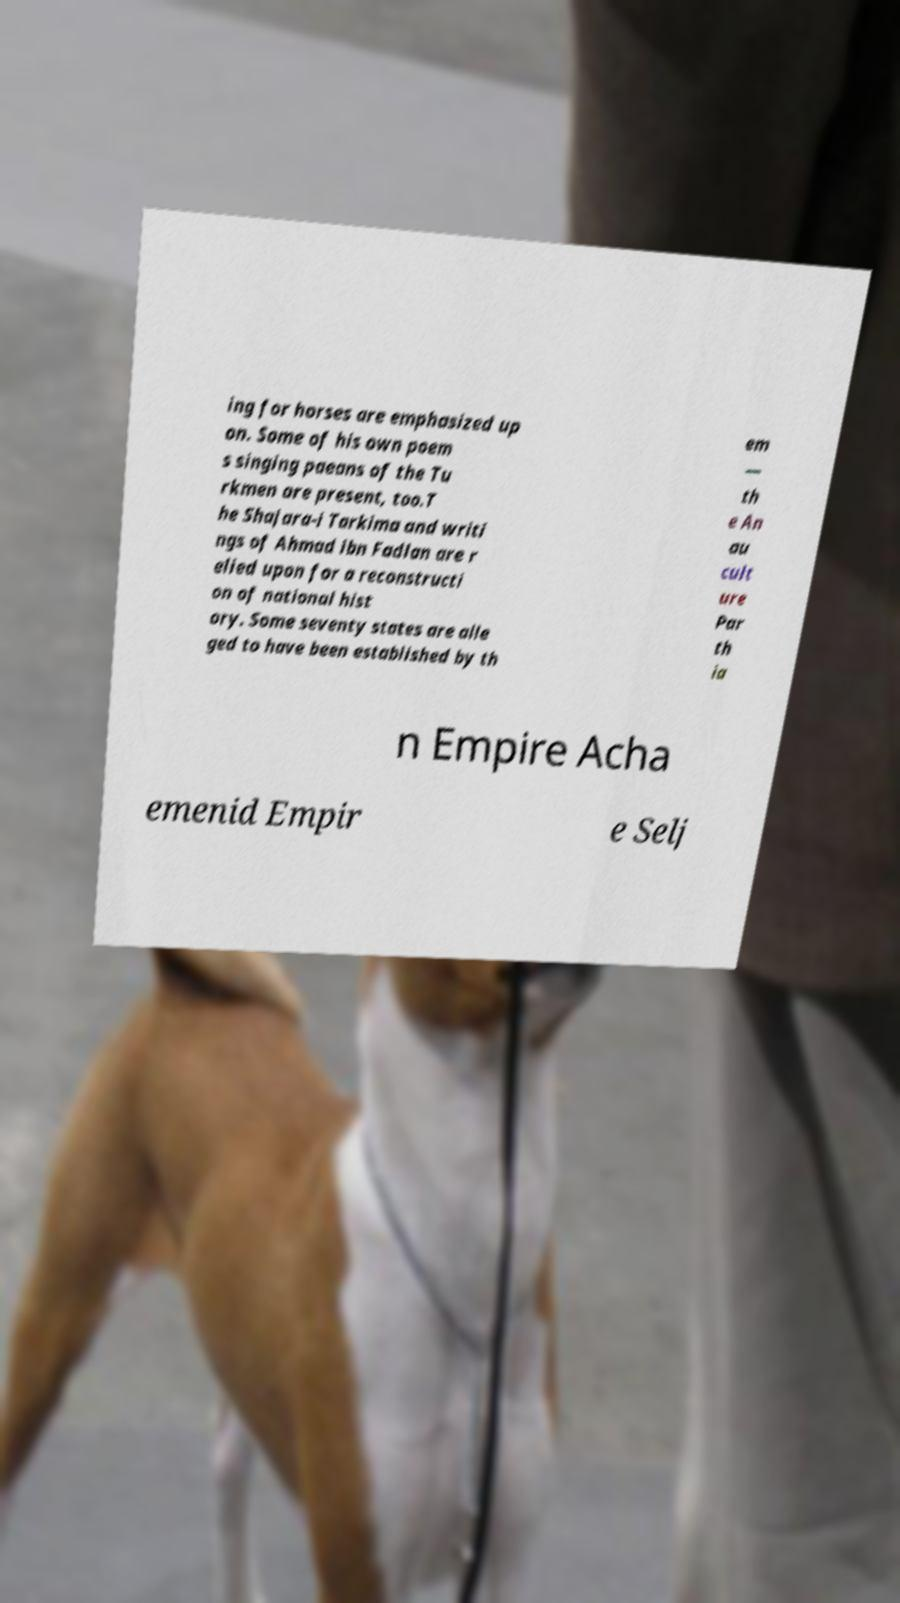There's text embedded in this image that I need extracted. Can you transcribe it verbatim? ing for horses are emphasized up on. Some of his own poem s singing paeans of the Tu rkmen are present, too.T he Shajara-i Tarkima and writi ngs of Ahmad ibn Fadlan are r elied upon for a reconstructi on of national hist ory. Some seventy states are alle ged to have been established by th em — th e An au cult ure Par th ia n Empire Acha emenid Empir e Selj 